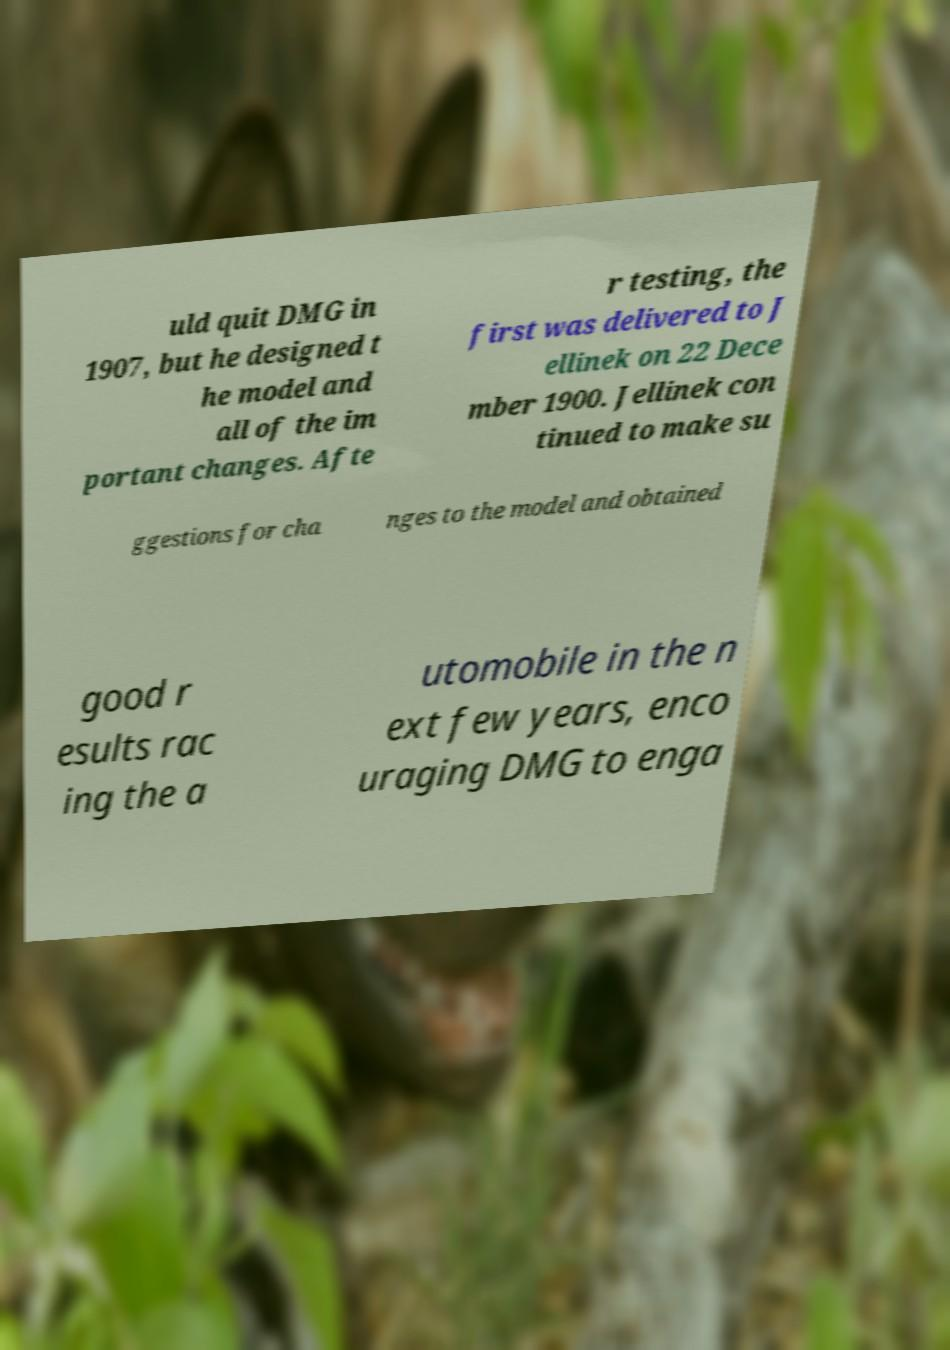Can you read and provide the text displayed in the image?This photo seems to have some interesting text. Can you extract and type it out for me? uld quit DMG in 1907, but he designed t he model and all of the im portant changes. Afte r testing, the first was delivered to J ellinek on 22 Dece mber 1900. Jellinek con tinued to make su ggestions for cha nges to the model and obtained good r esults rac ing the a utomobile in the n ext few years, enco uraging DMG to enga 